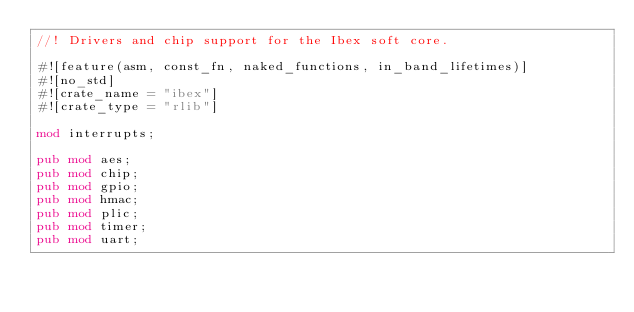<code> <loc_0><loc_0><loc_500><loc_500><_Rust_>//! Drivers and chip support for the Ibex soft core.

#![feature(asm, const_fn, naked_functions, in_band_lifetimes)]
#![no_std]
#![crate_name = "ibex"]
#![crate_type = "rlib"]

mod interrupts;

pub mod aes;
pub mod chip;
pub mod gpio;
pub mod hmac;
pub mod plic;
pub mod timer;
pub mod uart;
</code> 